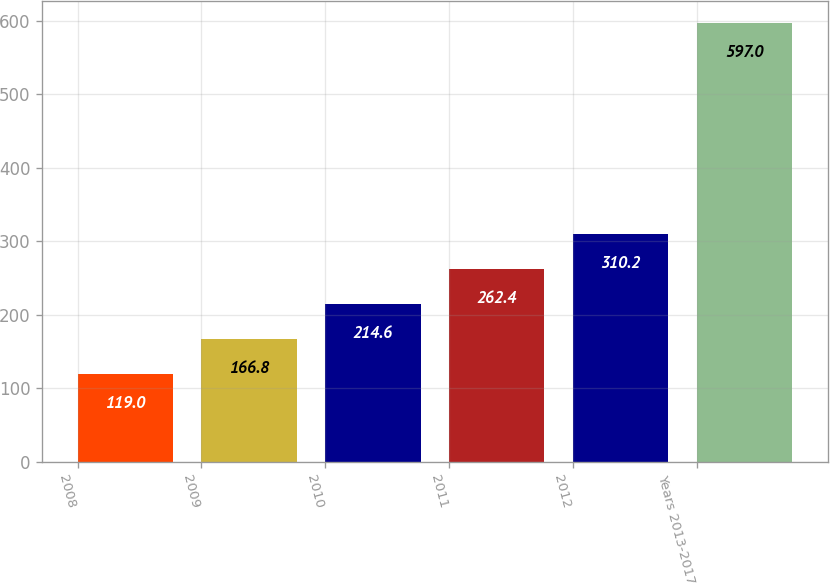Convert chart to OTSL. <chart><loc_0><loc_0><loc_500><loc_500><bar_chart><fcel>2008<fcel>2009<fcel>2010<fcel>2011<fcel>2012<fcel>Years 2013-2017<nl><fcel>119<fcel>166.8<fcel>214.6<fcel>262.4<fcel>310.2<fcel>597<nl></chart> 